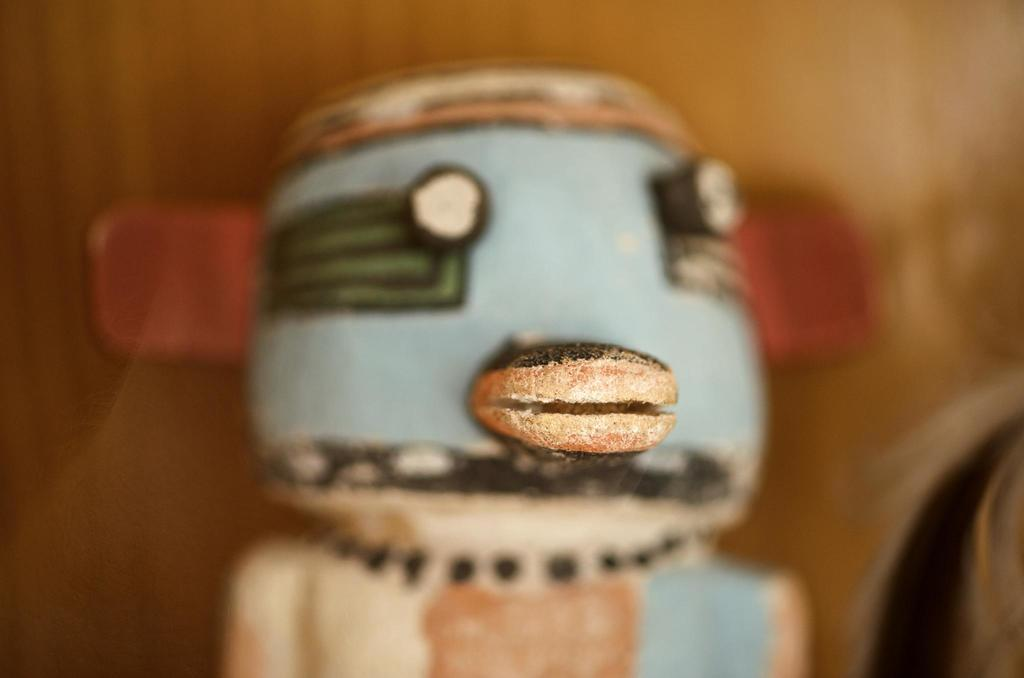What is the focus of the image? The image is zoomed in on a central object that appears to be a toy. How is the background of the image depicted? The background of the image is blurry. Are there any other objects visible in the image besides the central object? Yes, there are objects in the background of the image. Can you tell me how many people are in the group in the image? There is no group of people present in the image; it features a zoomed-in view of a toy with a blurry background. What type of cave is visible in the image? There is no cave present in the image; it features a toy and a blurry background. 